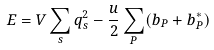Convert formula to latex. <formula><loc_0><loc_0><loc_500><loc_500>E = V \sum _ { s } q _ { s } ^ { 2 } - \frac { u } { 2 } \sum _ { P } ( b _ { P } + b _ { P } ^ { * } )</formula> 